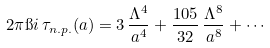Convert formula to latex. <formula><loc_0><loc_0><loc_500><loc_500>2 \pi \i i \, \tau _ { n . p . } ( a ) = 3 \, \frac { \Lambda ^ { 4 } } { a ^ { 4 } } + \frac { 1 0 5 } { 3 2 } \, \frac { \Lambda ^ { 8 } } { a ^ { 8 } } + \cdots</formula> 